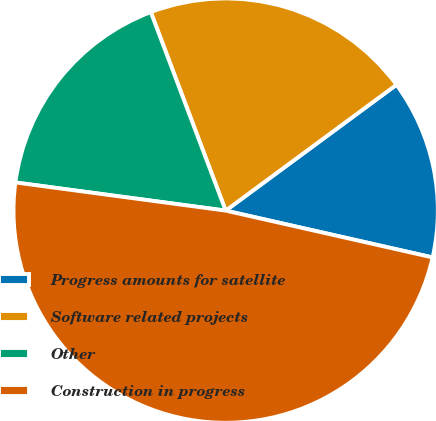Convert chart. <chart><loc_0><loc_0><loc_500><loc_500><pie_chart><fcel>Progress amounts for satellite<fcel>Software related projects<fcel>Other<fcel>Construction in progress<nl><fcel>13.65%<fcel>20.63%<fcel>17.14%<fcel>48.57%<nl></chart> 